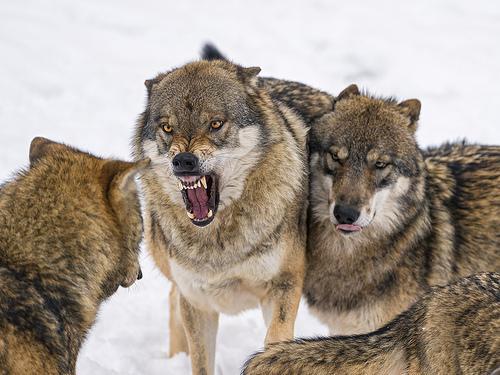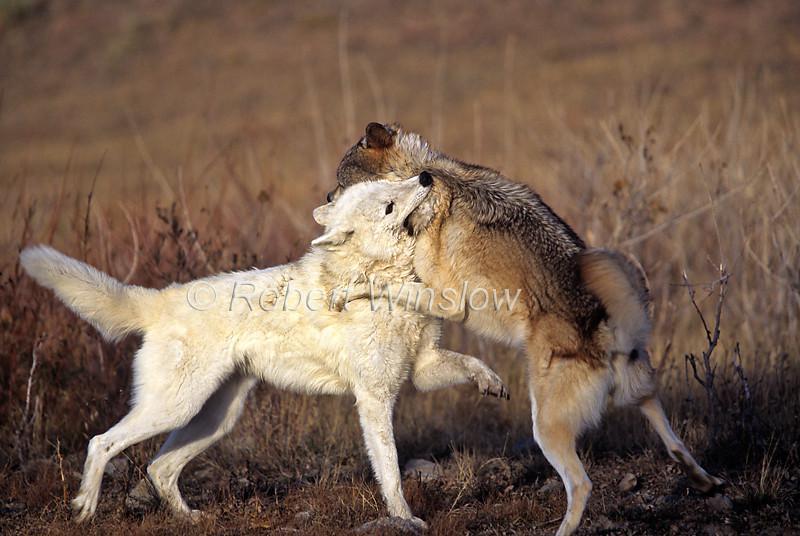The first image is the image on the left, the second image is the image on the right. Examine the images to the left and right. Is the description "One image shows at least three wolves in a confrontational scene, with the one at the center baring its fangs with a wide open mouth, and the other image shows a wolf jumping on another wolf." accurate? Answer yes or no. Yes. The first image is the image on the left, the second image is the image on the right. For the images displayed, is the sentence "In at least one image, there are three wolves on snow with at least one with an open angry mouth." factually correct? Answer yes or no. Yes. 